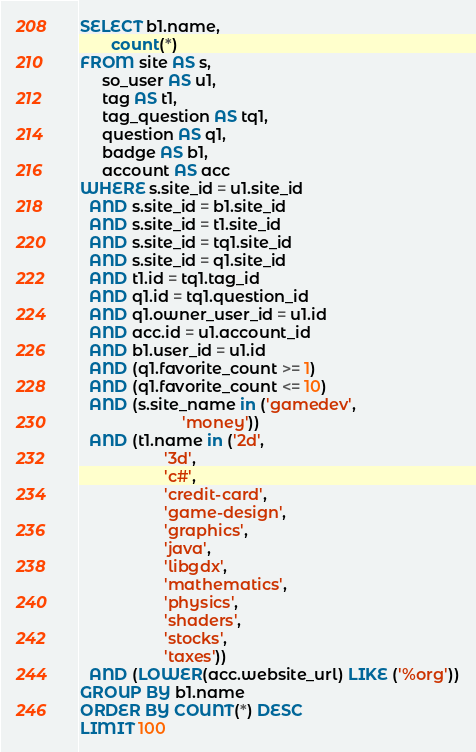<code> <loc_0><loc_0><loc_500><loc_500><_SQL_>SELECT b1.name,
       count(*)
FROM site AS s,
     so_user AS u1,
     tag AS t1,
     tag_question AS tq1,
     question AS q1,
     badge AS b1,
     account AS acc
WHERE s.site_id = u1.site_id
  AND s.site_id = b1.site_id
  AND s.site_id = t1.site_id
  AND s.site_id = tq1.site_id
  AND s.site_id = q1.site_id
  AND t1.id = tq1.tag_id
  AND q1.id = tq1.question_id
  AND q1.owner_user_id = u1.id
  AND acc.id = u1.account_id
  AND b1.user_id = u1.id
  AND (q1.favorite_count >= 1)
  AND (q1.favorite_count <= 10)
  AND (s.site_name in ('gamedev',
                       'money'))
  AND (t1.name in ('2d',
                   '3d',
                   'c#',
                   'credit-card',
                   'game-design',
                   'graphics',
                   'java',
                   'libgdx',
                   'mathematics',
                   'physics',
                   'shaders',
                   'stocks',
                   'taxes'))
  AND (LOWER(acc.website_url) LIKE ('%org'))
GROUP BY b1.name
ORDER BY COUNT(*) DESC
LIMIT 100</code> 